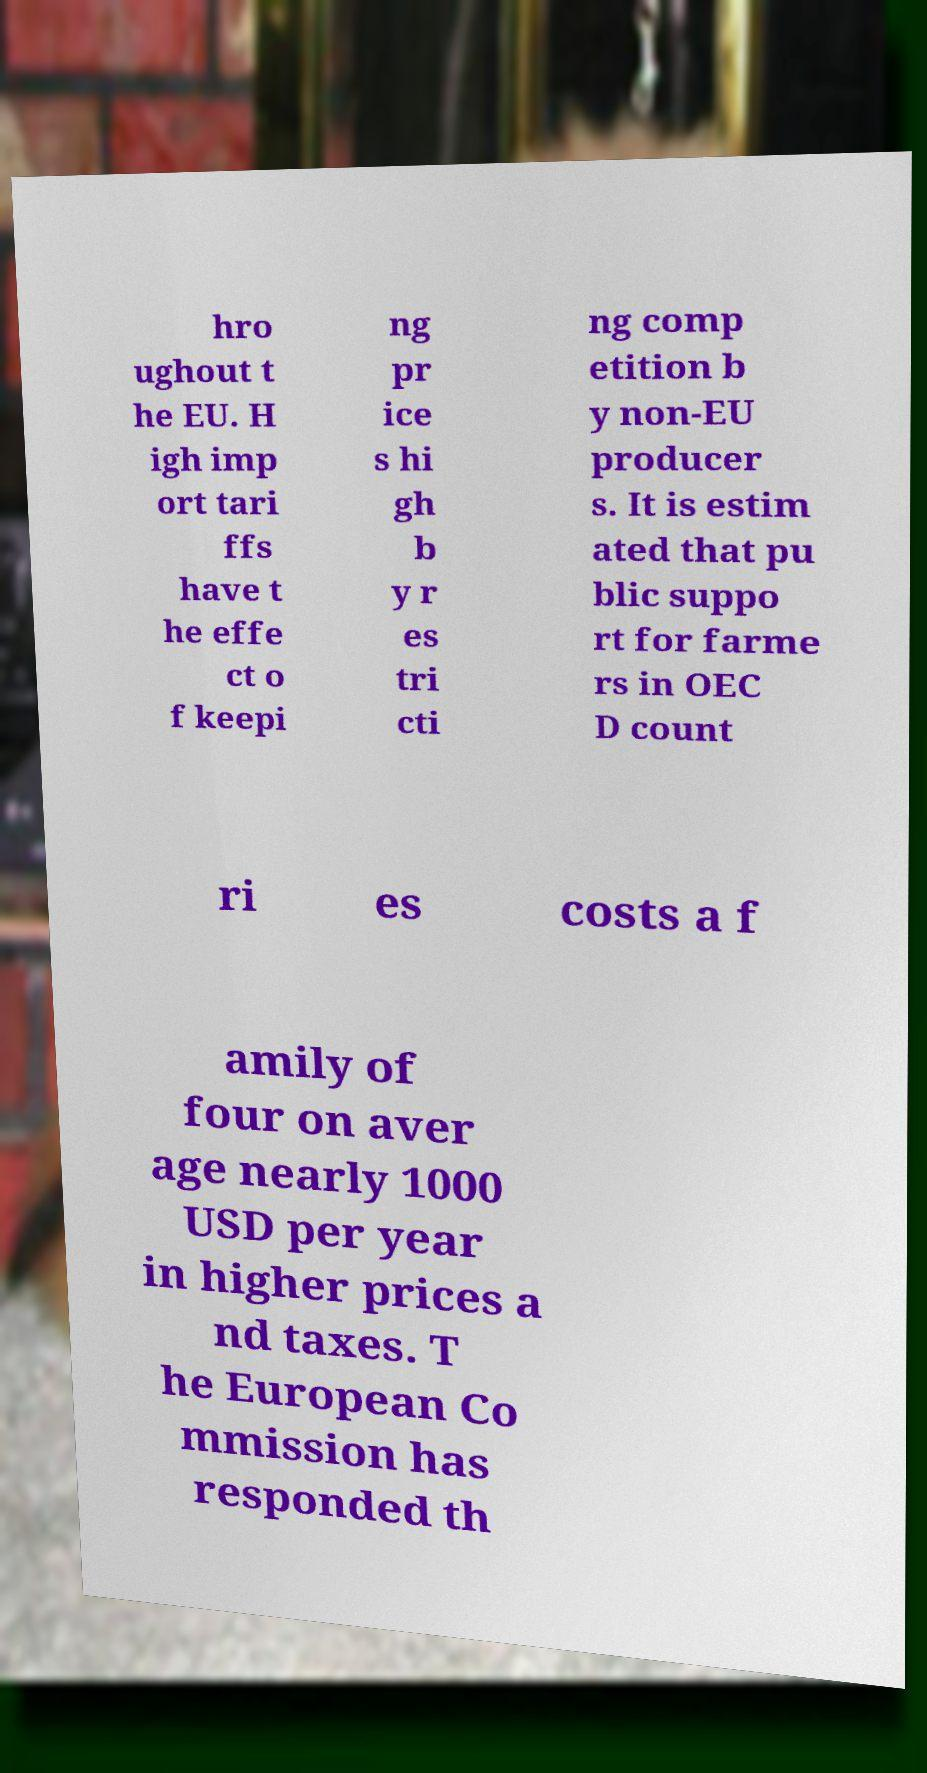I need the written content from this picture converted into text. Can you do that? hro ughout t he EU. H igh imp ort tari ffs have t he effe ct o f keepi ng pr ice s hi gh b y r es tri cti ng comp etition b y non-EU producer s. It is estim ated that pu blic suppo rt for farme rs in OEC D count ri es costs a f amily of four on aver age nearly 1000 USD per year in higher prices a nd taxes. T he European Co mmission has responded th 